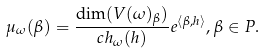<formula> <loc_0><loc_0><loc_500><loc_500>\mu _ { \omega } ( \beta ) = \frac { \dim ( V ( \omega ) _ { \beta } ) } { c h _ { \omega } ( h ) } e ^ { \langle \beta , h \rangle } , \beta \in P .</formula> 